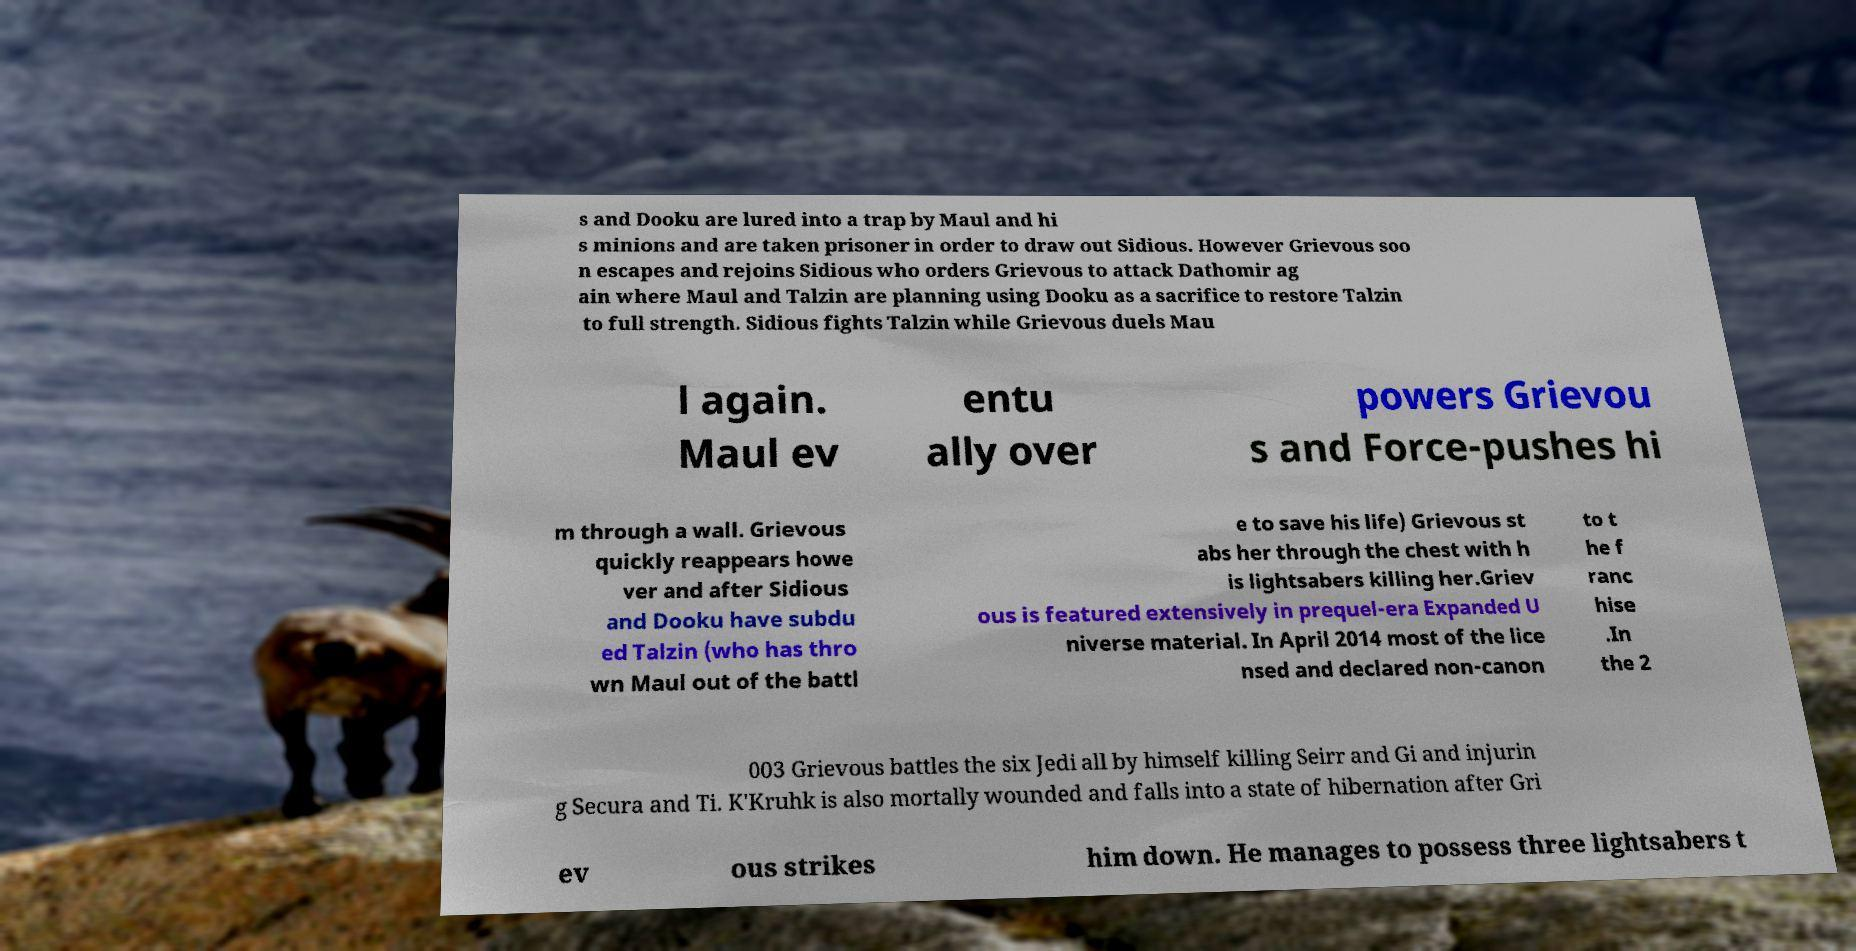There's text embedded in this image that I need extracted. Can you transcribe it verbatim? s and Dooku are lured into a trap by Maul and hi s minions and are taken prisoner in order to draw out Sidious. However Grievous soo n escapes and rejoins Sidious who orders Grievous to attack Dathomir ag ain where Maul and Talzin are planning using Dooku as a sacrifice to restore Talzin to full strength. Sidious fights Talzin while Grievous duels Mau l again. Maul ev entu ally over powers Grievou s and Force-pushes hi m through a wall. Grievous quickly reappears howe ver and after Sidious and Dooku have subdu ed Talzin (who has thro wn Maul out of the battl e to save his life) Grievous st abs her through the chest with h is lightsabers killing her.Griev ous is featured extensively in prequel-era Expanded U niverse material. In April 2014 most of the lice nsed and declared non-canon to t he f ranc hise .In the 2 003 Grievous battles the six Jedi all by himself killing Seirr and Gi and injurin g Secura and Ti. K'Kruhk is also mortally wounded and falls into a state of hibernation after Gri ev ous strikes him down. He manages to possess three lightsabers t 